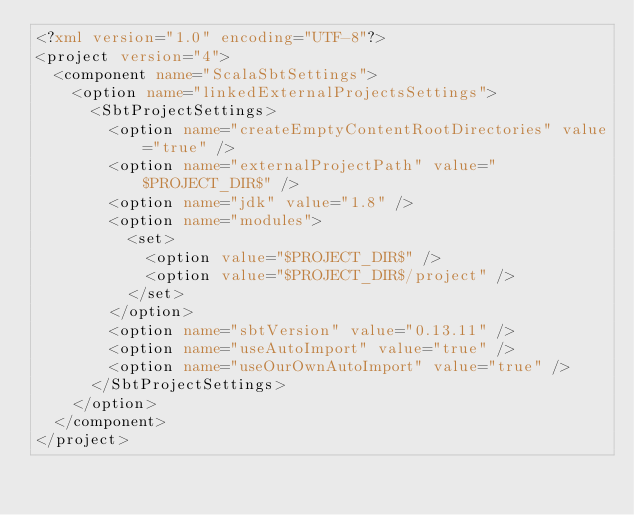Convert code to text. <code><loc_0><loc_0><loc_500><loc_500><_XML_><?xml version="1.0" encoding="UTF-8"?>
<project version="4">
  <component name="ScalaSbtSettings">
    <option name="linkedExternalProjectsSettings">
      <SbtProjectSettings>
        <option name="createEmptyContentRootDirectories" value="true" />
        <option name="externalProjectPath" value="$PROJECT_DIR$" />
        <option name="jdk" value="1.8" />
        <option name="modules">
          <set>
            <option value="$PROJECT_DIR$" />
            <option value="$PROJECT_DIR$/project" />
          </set>
        </option>
        <option name="sbtVersion" value="0.13.11" />
        <option name="useAutoImport" value="true" />
        <option name="useOurOwnAutoImport" value="true" />
      </SbtProjectSettings>
    </option>
  </component>
</project></code> 